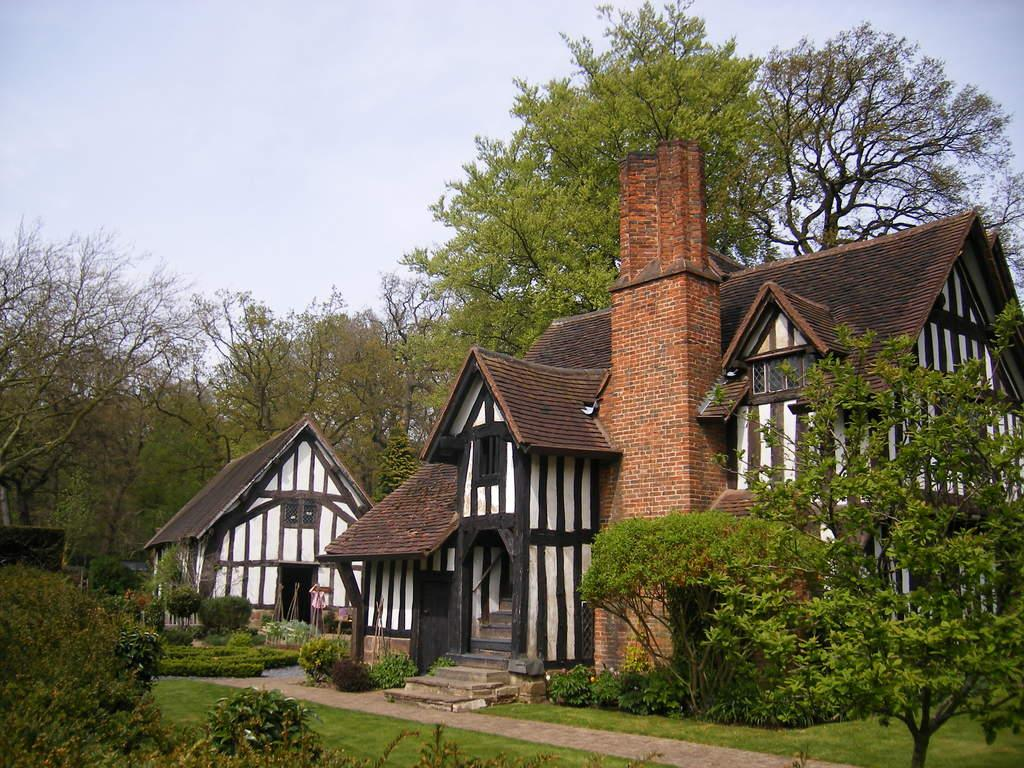What is located in the middle of the picture? There are trees, a house, a person, plants, and grass in the middle of the picture. What type of vegetation can be seen in the picture? There are plants and trees in the picture. What is the ground made of in the picture? There is grass in the picture. What is visible at the top of the picture? The sky is visible at the top of the picture. What is present at the bottom of the picture? There are plants, grass, and a path at the bottom of the picture. Is it raining in the picture? There is no mention of rain in the provided facts, so we cannot determine if it is raining in the picture. What type of house is located at the place in the picture? The provided facts do not mention a specific type of house or a place, so we cannot determine the type of house or its location in the picture. 